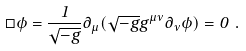<formula> <loc_0><loc_0><loc_500><loc_500>\Box \phi = \frac { 1 } { \sqrt { - g } } \partial _ { \mu } ( \sqrt { - g } g ^ { \mu \nu } \partial _ { \nu } \phi ) = 0 \ .</formula> 